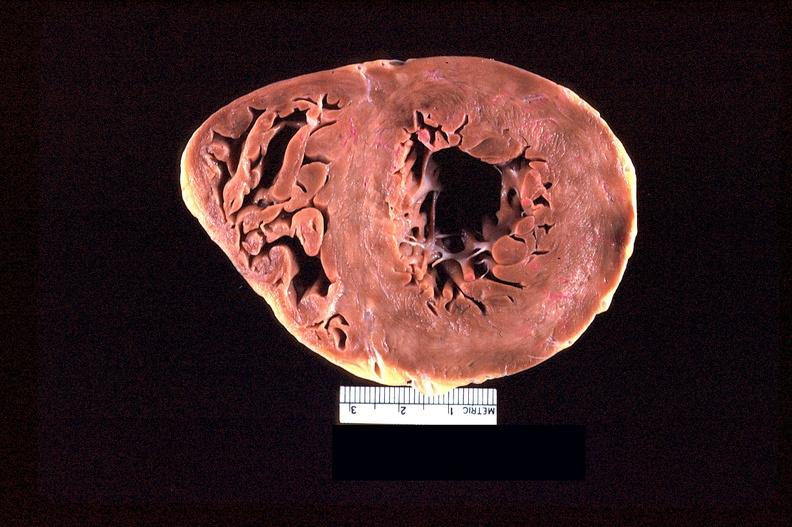s slide present?
Answer the question using a single word or phrase. No 